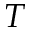<formula> <loc_0><loc_0><loc_500><loc_500>T</formula> 